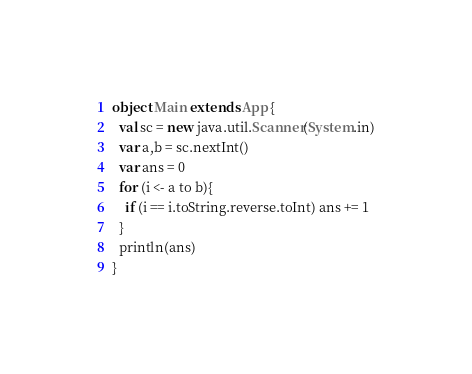<code> <loc_0><loc_0><loc_500><loc_500><_Scala_>object Main extends App {
  val sc = new java.util.Scanner(System.in)
  var a,b = sc.nextInt()
  var ans = 0
  for (i <- a to b){
    if (i == i.toString.reverse.toInt) ans += 1
  }
  println(ans)
}
</code> 